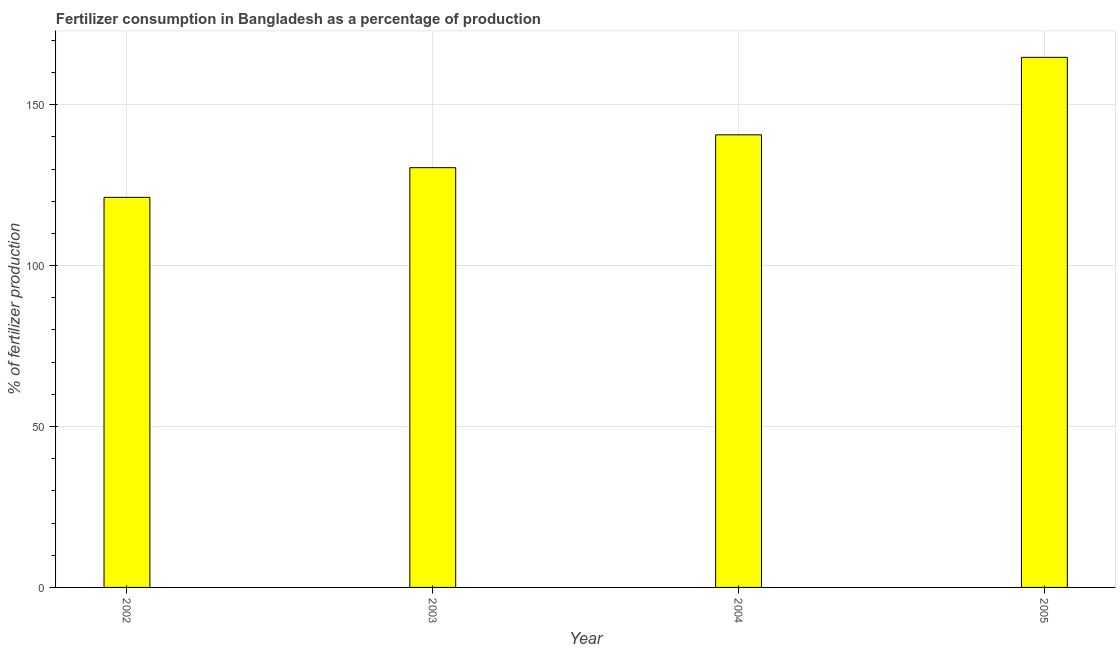What is the title of the graph?
Make the answer very short. Fertilizer consumption in Bangladesh as a percentage of production. What is the label or title of the Y-axis?
Your response must be concise. % of fertilizer production. What is the amount of fertilizer consumption in 2005?
Offer a very short reply. 164.73. Across all years, what is the maximum amount of fertilizer consumption?
Make the answer very short. 164.73. Across all years, what is the minimum amount of fertilizer consumption?
Your answer should be very brief. 121.21. What is the sum of the amount of fertilizer consumption?
Make the answer very short. 557.03. What is the difference between the amount of fertilizer consumption in 2003 and 2005?
Make the answer very short. -34.29. What is the average amount of fertilizer consumption per year?
Your response must be concise. 139.26. What is the median amount of fertilizer consumption?
Your answer should be very brief. 135.54. In how many years, is the amount of fertilizer consumption greater than 90 %?
Your answer should be compact. 4. Do a majority of the years between 2004 and 2005 (inclusive) have amount of fertilizer consumption greater than 150 %?
Ensure brevity in your answer.  No. What is the ratio of the amount of fertilizer consumption in 2003 to that in 2004?
Your answer should be very brief. 0.93. Is the difference between the amount of fertilizer consumption in 2003 and 2005 greater than the difference between any two years?
Keep it short and to the point. No. What is the difference between the highest and the second highest amount of fertilizer consumption?
Give a very brief answer. 24.09. What is the difference between the highest and the lowest amount of fertilizer consumption?
Offer a terse response. 43.52. In how many years, is the amount of fertilizer consumption greater than the average amount of fertilizer consumption taken over all years?
Your answer should be compact. 2. How many bars are there?
Offer a very short reply. 4. What is the difference between two consecutive major ticks on the Y-axis?
Your answer should be very brief. 50. What is the % of fertilizer production in 2002?
Offer a terse response. 121.21. What is the % of fertilizer production of 2003?
Offer a terse response. 130.44. What is the % of fertilizer production of 2004?
Keep it short and to the point. 140.64. What is the % of fertilizer production in 2005?
Make the answer very short. 164.73. What is the difference between the % of fertilizer production in 2002 and 2003?
Keep it short and to the point. -9.23. What is the difference between the % of fertilizer production in 2002 and 2004?
Keep it short and to the point. -19.43. What is the difference between the % of fertilizer production in 2002 and 2005?
Make the answer very short. -43.52. What is the difference between the % of fertilizer production in 2003 and 2004?
Keep it short and to the point. -10.2. What is the difference between the % of fertilizer production in 2003 and 2005?
Provide a succinct answer. -34.29. What is the difference between the % of fertilizer production in 2004 and 2005?
Ensure brevity in your answer.  -24.09. What is the ratio of the % of fertilizer production in 2002 to that in 2003?
Give a very brief answer. 0.93. What is the ratio of the % of fertilizer production in 2002 to that in 2004?
Provide a short and direct response. 0.86. What is the ratio of the % of fertilizer production in 2002 to that in 2005?
Give a very brief answer. 0.74. What is the ratio of the % of fertilizer production in 2003 to that in 2004?
Your answer should be compact. 0.93. What is the ratio of the % of fertilizer production in 2003 to that in 2005?
Provide a succinct answer. 0.79. What is the ratio of the % of fertilizer production in 2004 to that in 2005?
Keep it short and to the point. 0.85. 